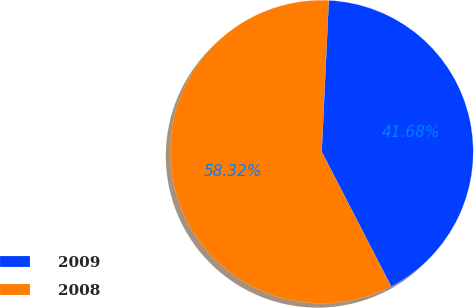Convert chart to OTSL. <chart><loc_0><loc_0><loc_500><loc_500><pie_chart><fcel>2009<fcel>2008<nl><fcel>41.68%<fcel>58.32%<nl></chart> 